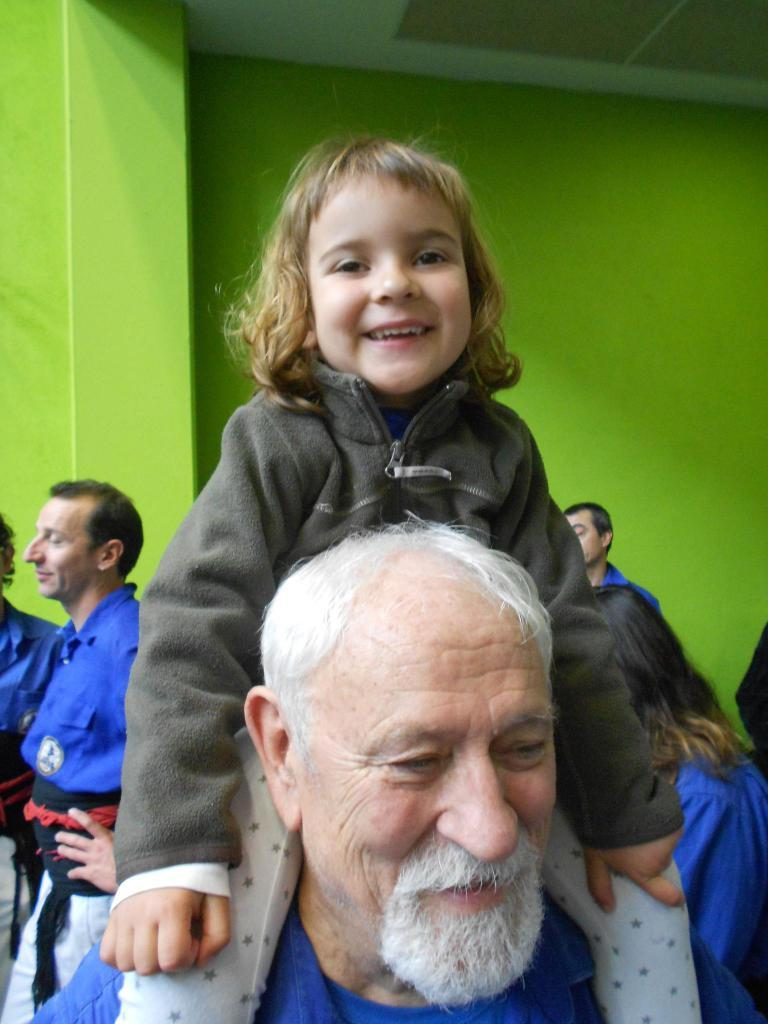Who is the main subject in the image? The main subject in the image is a small girl. What is the girl doing in the image? The girl is sitting on a man. What is the girl's expression in the image? The girl is smiling. Are there other people in the image besides the girl and the man? Yes, there are people standing in the image. What can be seen in the background of the image? There appears to be a green wall in the image. What type of fruit can be heard making noise in the image? There is no fruit present in the image, and therefore no such noise can be heard. 